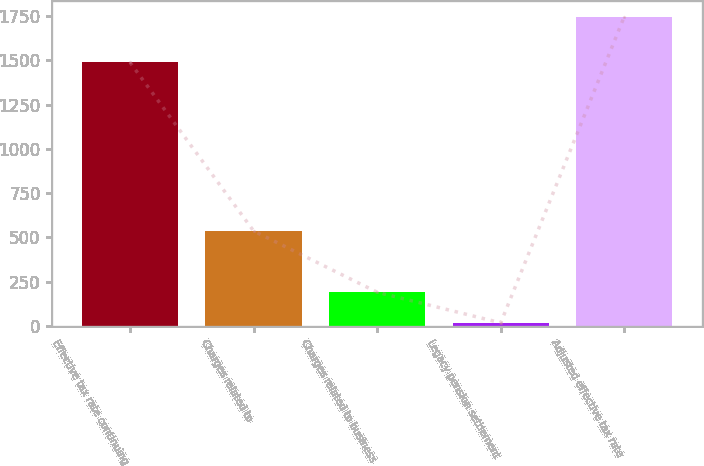<chart> <loc_0><loc_0><loc_500><loc_500><bar_chart><fcel>Effective tax rate continuing<fcel>Charges related to<fcel>Charges related to business<fcel>Legacy pension settlement<fcel>Adjusted effective tax rate<nl><fcel>1489<fcel>537<fcel>191<fcel>18<fcel>1748<nl></chart> 